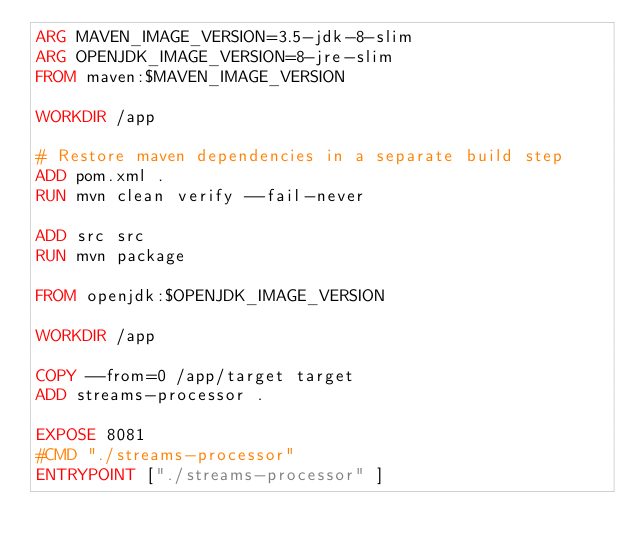Convert code to text. <code><loc_0><loc_0><loc_500><loc_500><_Dockerfile_>ARG MAVEN_IMAGE_VERSION=3.5-jdk-8-slim
ARG OPENJDK_IMAGE_VERSION=8-jre-slim
FROM maven:$MAVEN_IMAGE_VERSION

WORKDIR /app

# Restore maven dependencies in a separate build step
ADD pom.xml .
RUN mvn clean verify --fail-never

ADD src src
RUN mvn package

FROM openjdk:$OPENJDK_IMAGE_VERSION

WORKDIR /app

COPY --from=0 /app/target target
ADD streams-processor .

EXPOSE 8081
#CMD "./streams-processor"
ENTRYPOINT ["./streams-processor" ]
</code> 